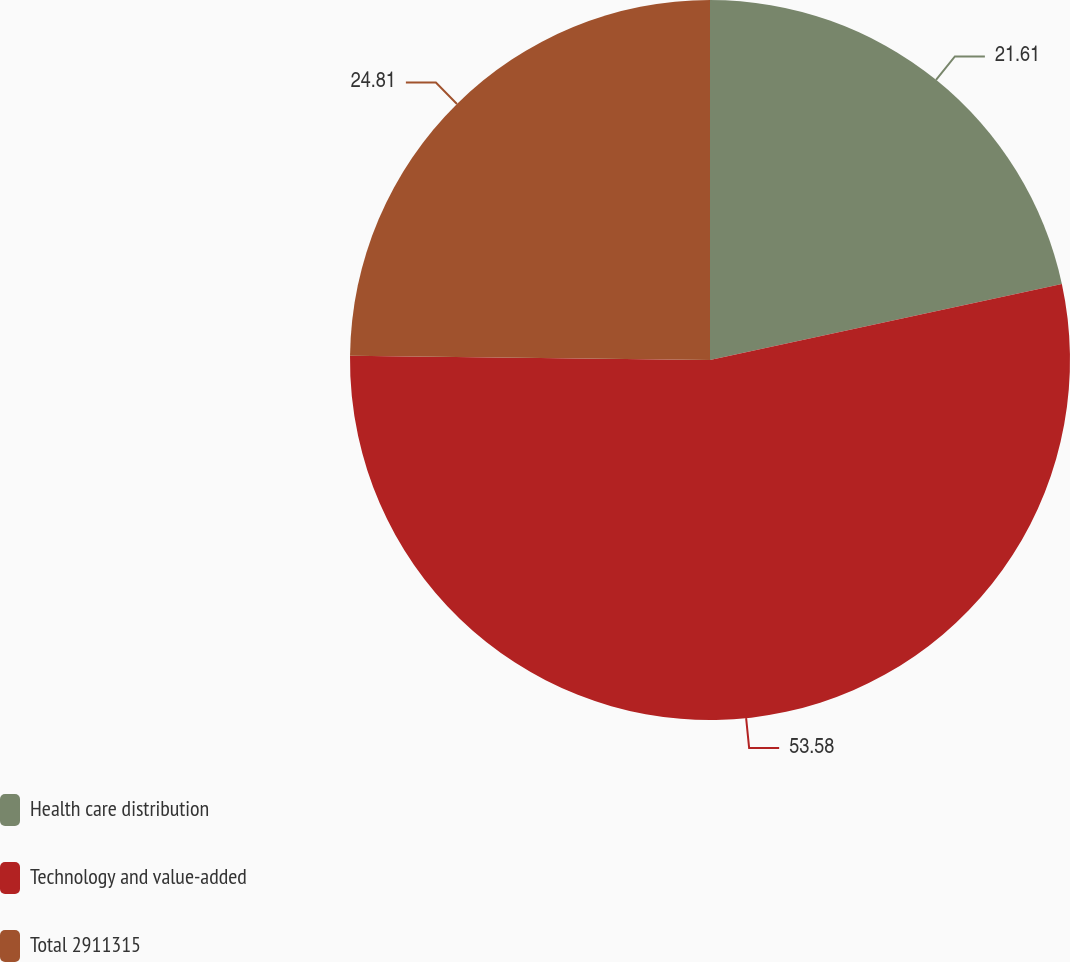Convert chart to OTSL. <chart><loc_0><loc_0><loc_500><loc_500><pie_chart><fcel>Health care distribution<fcel>Technology and value-added<fcel>Total 2911315<nl><fcel>21.61%<fcel>53.58%<fcel>24.81%<nl></chart> 